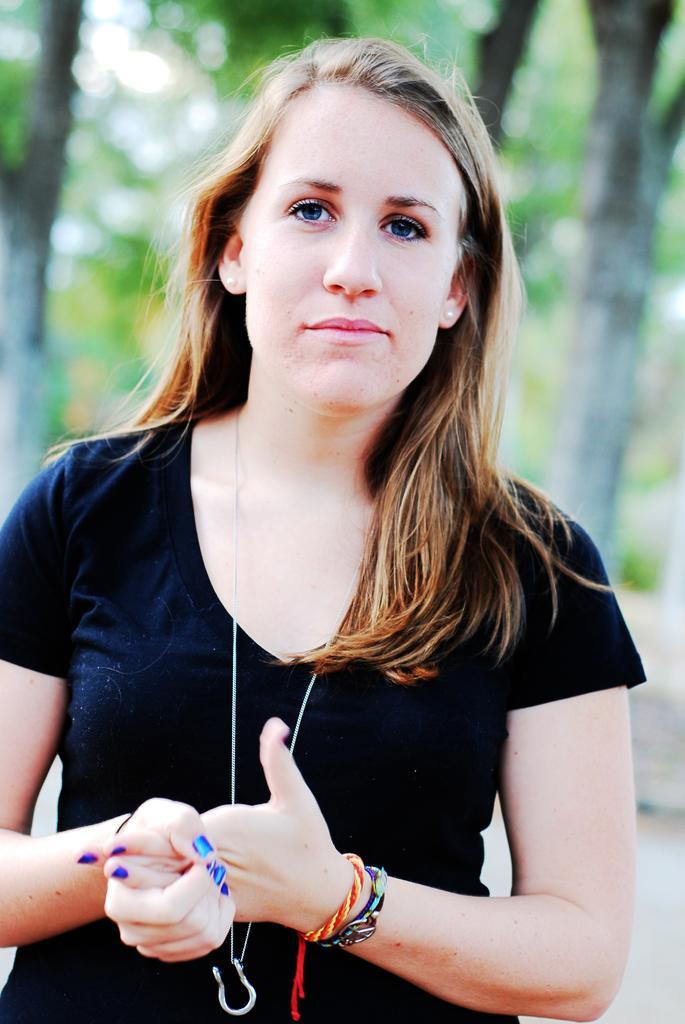Could you give a brief overview of what you see in this image? In this image there is a lady standing on the road behind that there are so many trees. 